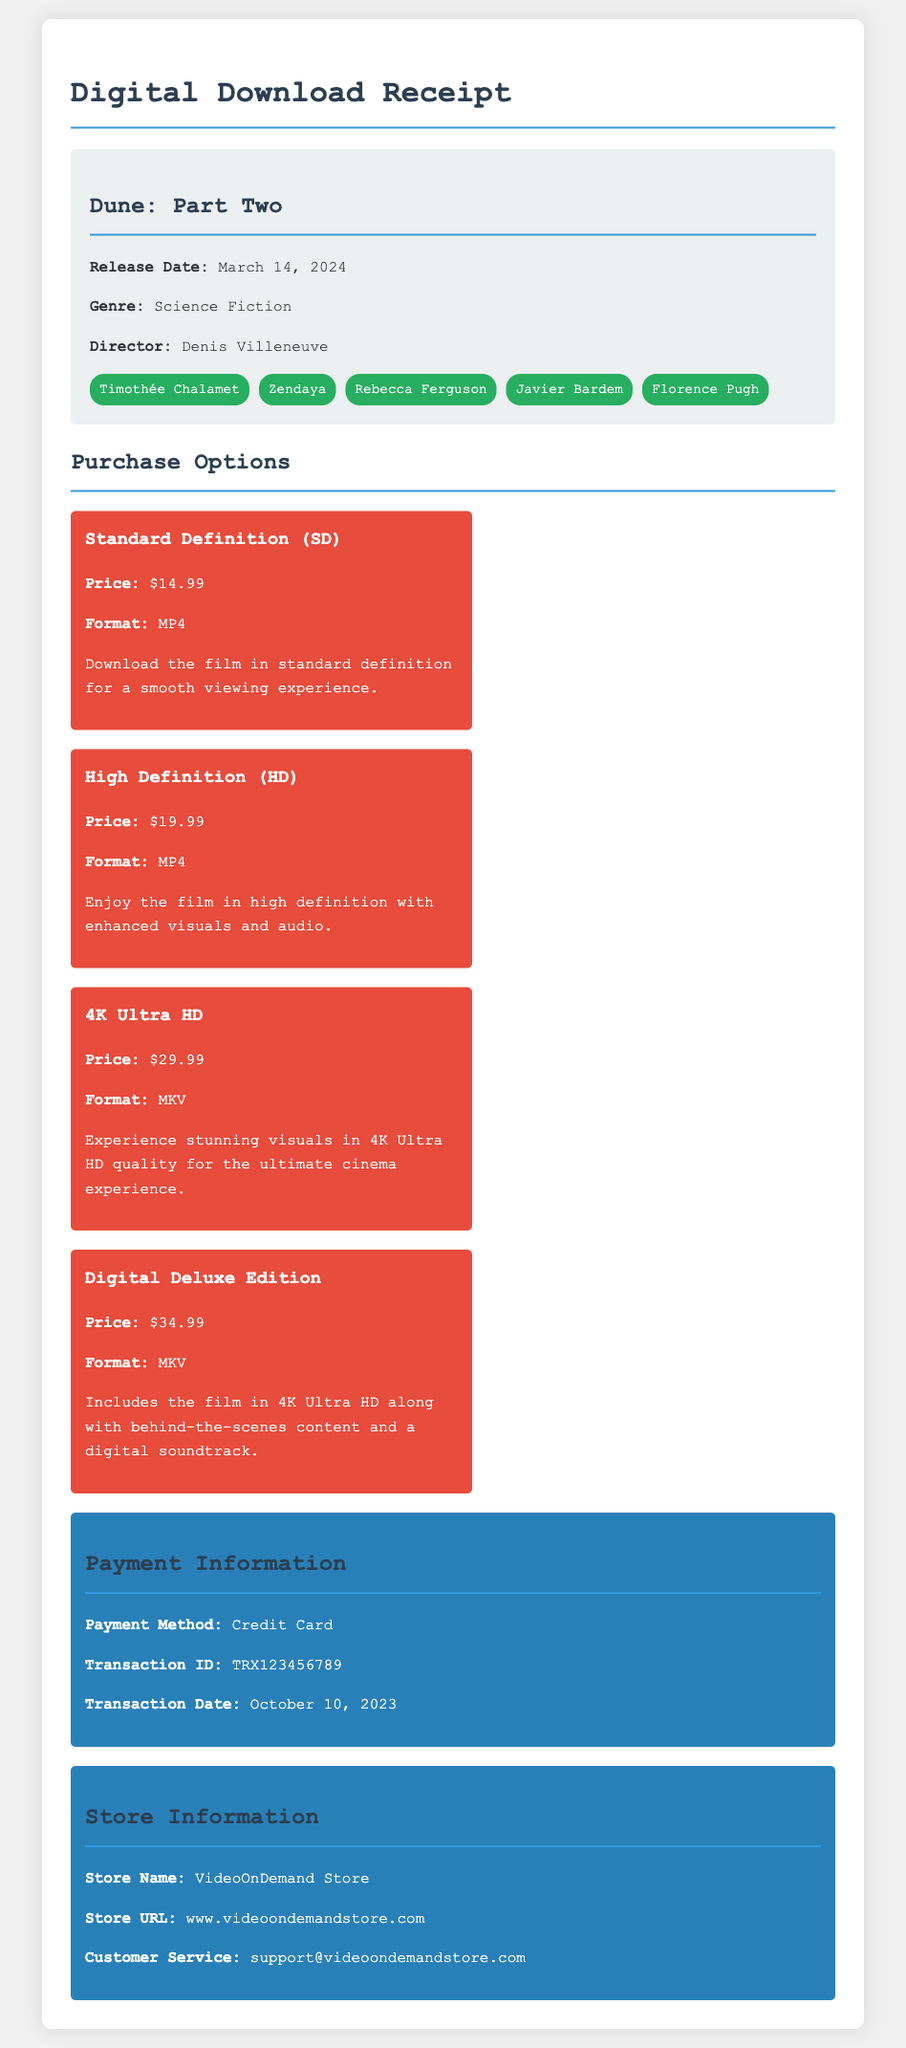what is the release date of the film? The release date is explicitly mentioned in the film information section of the document.
Answer: March 14, 2024 what is the price of the Digital Deluxe Edition? The price is stated in the purchase options section under the Digital Deluxe Edition.
Answer: $34.99 what format is the High Definition option available in? The format is listed in the details of the High Definition purchase option.
Answer: MP4 who is the director of the film? The director's name appears in the film information section of the document.
Answer: Denis Villeneuve how many purchase options are available? The number of purchase options can be counted from the purchase options section of the document.
Answer: 4 which payment method was used for this transaction? The payment method is listed in the payment information section.
Answer: Credit Card what does the Digital Deluxe Edition include? The contents included in the Digital Deluxe Edition are described in its features.
Answer: behind-the-scenes content and a digital soundtrack what is the store URL? The store URL is provided in the store information section of the document.
Answer: www.videoondemandstore.com what transaction date is listed in the receipt? The transaction date is specified in the payment information section.
Answer: October 10, 2023 